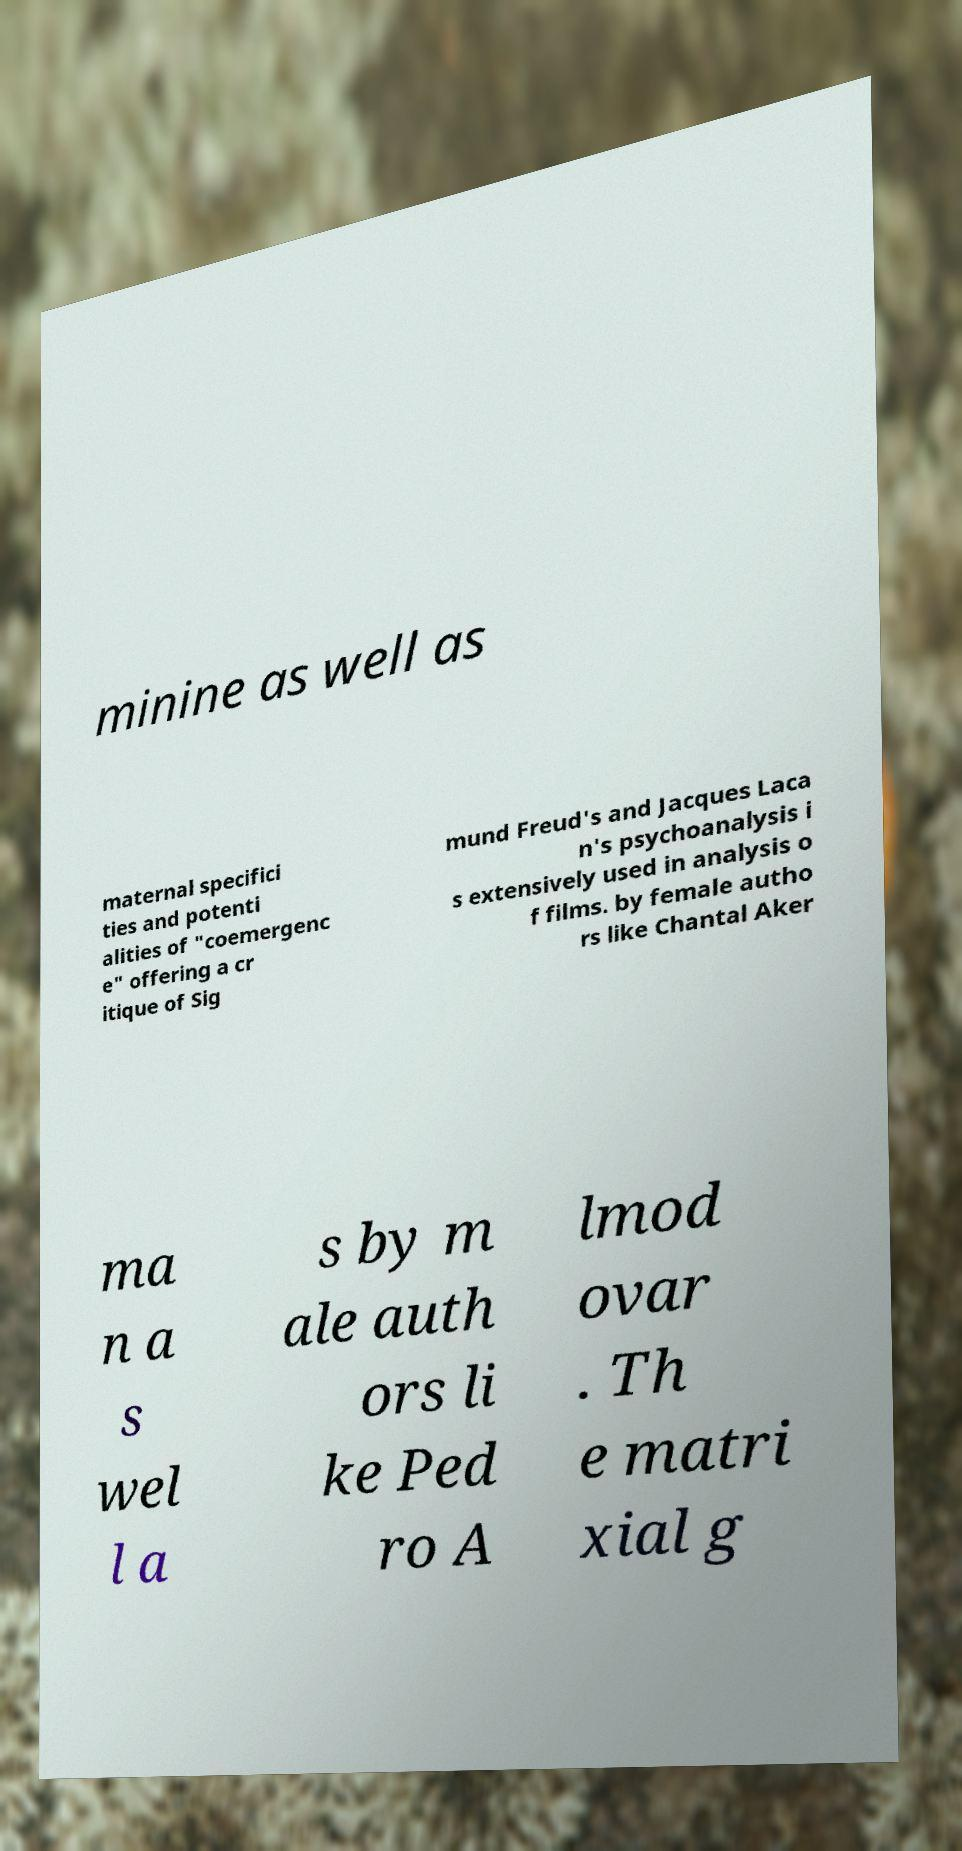Can you read and provide the text displayed in the image?This photo seems to have some interesting text. Can you extract and type it out for me? minine as well as maternal specifici ties and potenti alities of "coemergenc e" offering a cr itique of Sig mund Freud's and Jacques Laca n's psychoanalysis i s extensively used in analysis o f films. by female autho rs like Chantal Aker ma n a s wel l a s by m ale auth ors li ke Ped ro A lmod ovar . Th e matri xial g 